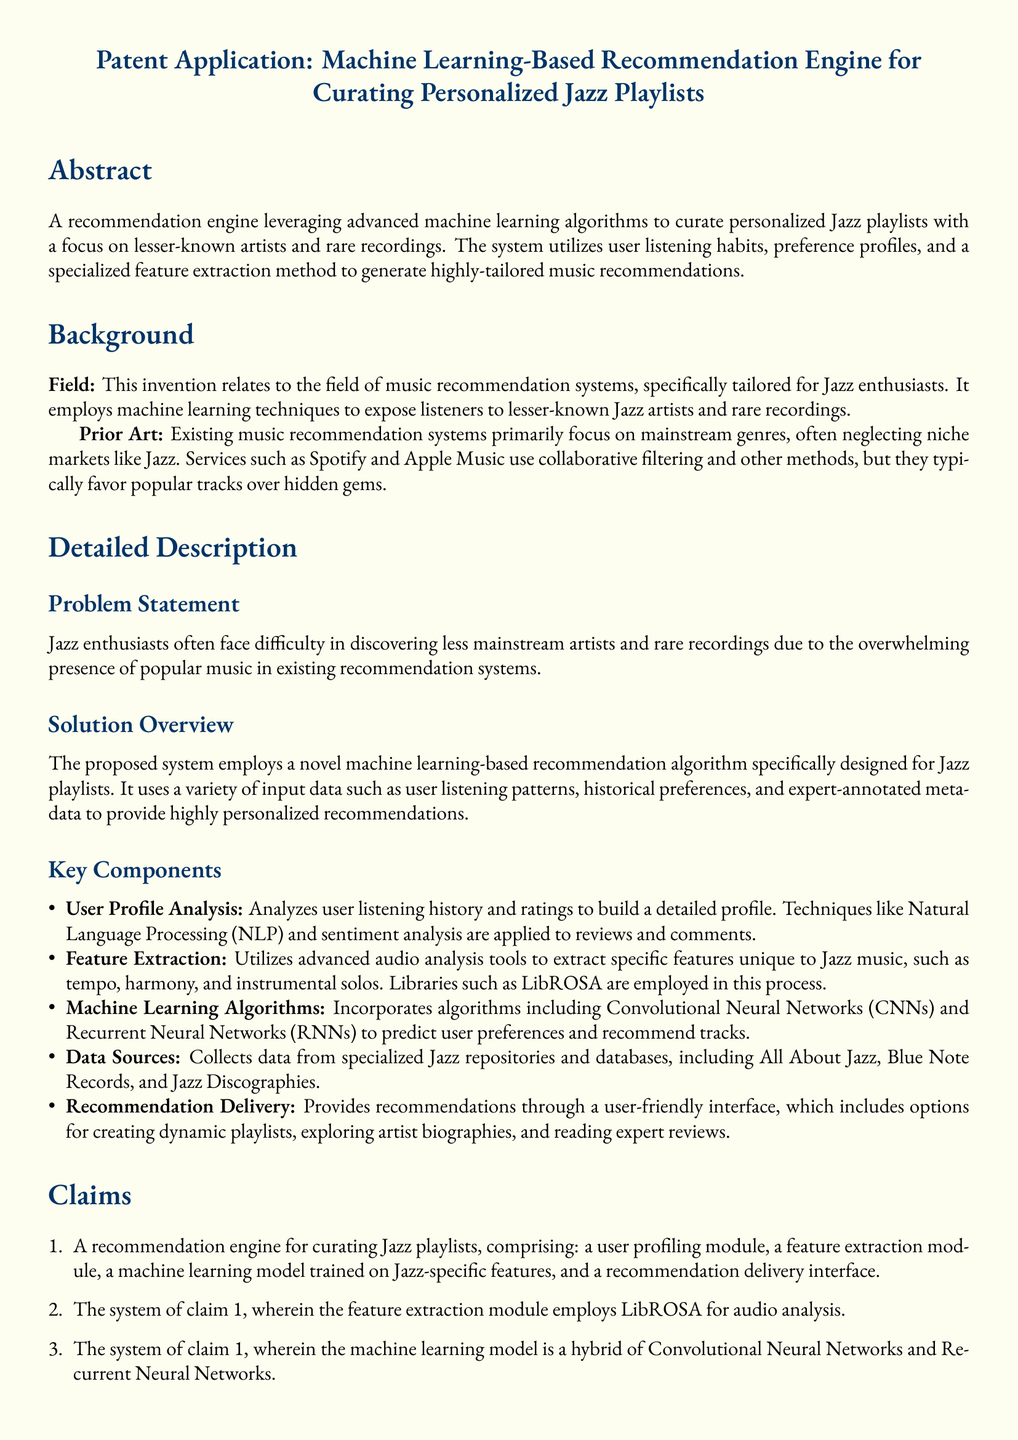What is the primary focus of the recommendation engine? The recommendation engine focuses on creating personalized Jazz playlists, emphasizing lesser-known artists and rare recordings.
Answer: Personalized Jazz playlists What method does the feature extraction module utilize? The feature extraction module employs LibROSA for audio analysis of Jazz music.
Answer: LibROSA Which machine learning algorithms are incorporated in the system? The system incorporates a hybrid of Convolutional Neural Networks and Recurrent Neural Networks as its machine learning algorithms.
Answer: Convolutional Neural Networks and Recurrent Neural Networks What is a key challenge faced by Jazz enthusiasts according to the document? Jazz enthusiasts struggle to discover less mainstream artists and rare recordings amidst popular music overwhelming existing recommendation systems.
Answer: Discovering less mainstream artists How does the system analyze user preferences? The system analyzes user preferences through user listening history and ratings to build a detailed user profile.
Answer: User listening history and ratings What are the data sources for the system? The system collects data from specialized Jazz repositories and databases like All About Jazz, Blue Note Records, and Jazz Discographies.
Answer: All About Jazz, Blue Note Records, Jazz Discographies What is the type of document presented? The document is a patent application for a machine learning-based recommendation engine for Jazz music.
Answer: Patent application 